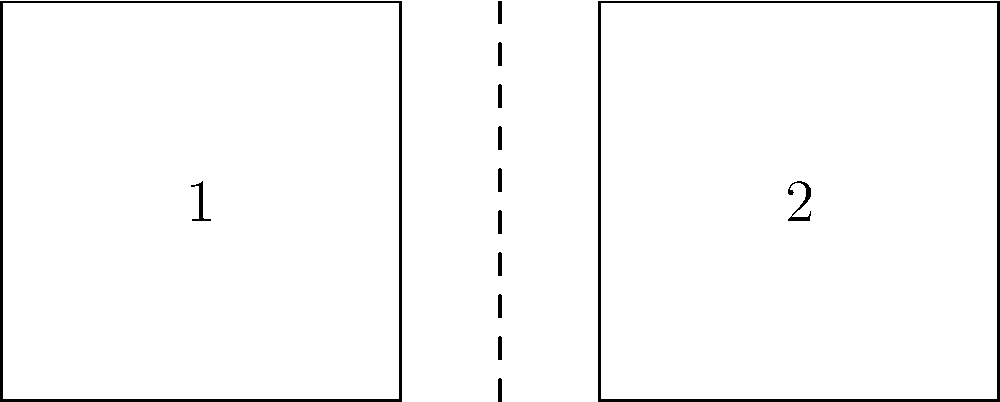Look at the two squares in the image. Which one is the mirror image of the other when the dashed line is the mirror? Choose 1 or 2. To determine which square is the mirror image of the other, we need to follow these steps:

1. Understand mirror images: A mirror image is like a reflection you see in a mirror. It appears reversed from left to right.

2. Identify the mirror line: The dashed line in the middle of the image acts as our mirror.

3. Compare the squares:
   - Square 1 is on the left side of the mirror line.
   - Square 2 is on the right side of the mirror line.

4. Check for reflection:
   - If we imagine folding the paper along the dashed line, Square 1 would perfectly overlap Square 2.
   - The right side of Square 1 touches the mirror line, just as the left side of Square 2 does.

5. Verify reversal:
   - The left-to-right order in Square 1 is reversed in Square 2, which is a key characteristic of mirror images.

Therefore, Square 2 is the mirror image of Square 1 when the dashed line acts as the mirror.
Answer: 2 